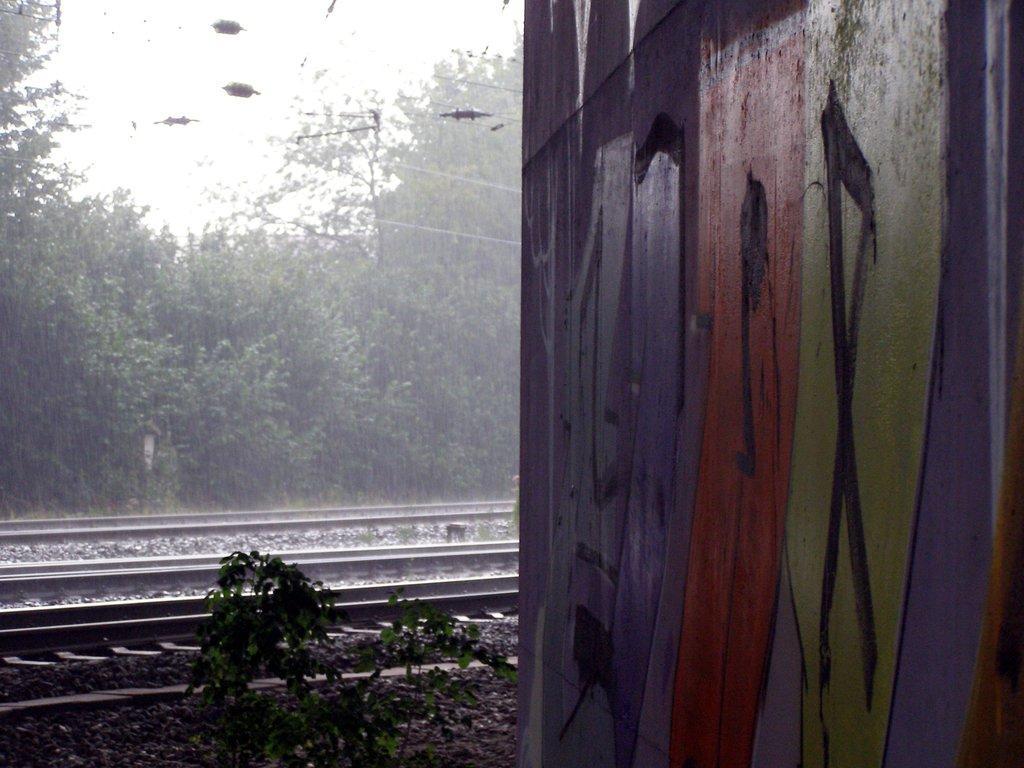Could you give a brief overview of what you see in this image? In this image we can see a wall on which graffiti design is drawn. In the background we can see a railway track ,group of trees ,plants and sky. 